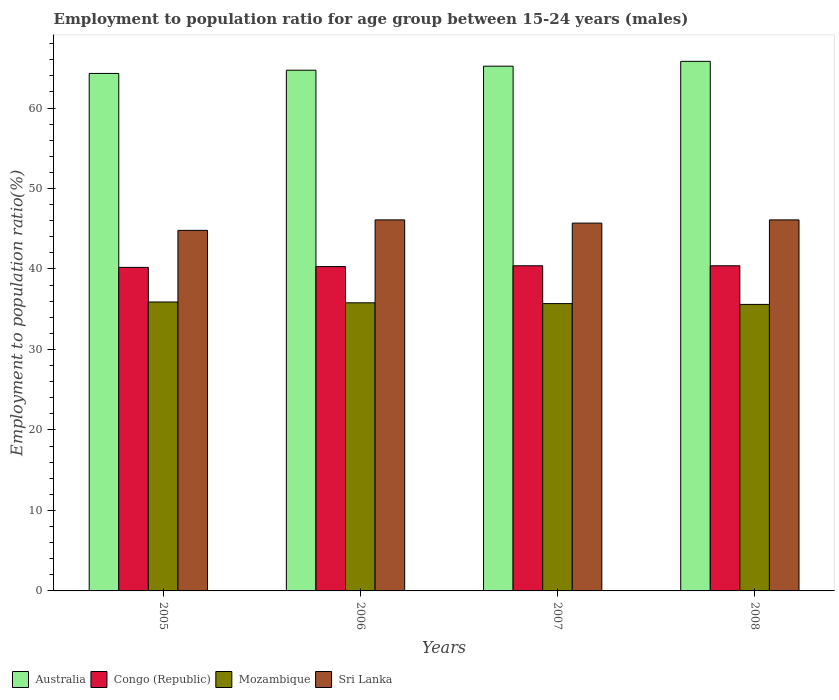How many different coloured bars are there?
Ensure brevity in your answer.  4. How many groups of bars are there?
Provide a succinct answer. 4. How many bars are there on the 3rd tick from the left?
Make the answer very short. 4. What is the employment to population ratio in Congo (Republic) in 2008?
Your response must be concise. 40.4. Across all years, what is the maximum employment to population ratio in Congo (Republic)?
Offer a terse response. 40.4. Across all years, what is the minimum employment to population ratio in Sri Lanka?
Give a very brief answer. 44.8. In which year was the employment to population ratio in Sri Lanka minimum?
Offer a terse response. 2005. What is the total employment to population ratio in Australia in the graph?
Offer a very short reply. 260. What is the difference between the employment to population ratio in Sri Lanka in 2005 and that in 2006?
Provide a short and direct response. -1.3. What is the difference between the employment to population ratio in Sri Lanka in 2008 and the employment to population ratio in Mozambique in 2007?
Offer a terse response. 10.4. What is the average employment to population ratio in Sri Lanka per year?
Your answer should be very brief. 45.67. In the year 2007, what is the difference between the employment to population ratio in Mozambique and employment to population ratio in Sri Lanka?
Provide a succinct answer. -10. What is the ratio of the employment to population ratio in Congo (Republic) in 2007 to that in 2008?
Your answer should be very brief. 1. What is the difference between the highest and the second highest employment to population ratio in Australia?
Give a very brief answer. 0.6. What is the difference between the highest and the lowest employment to population ratio in Mozambique?
Make the answer very short. 0.3. In how many years, is the employment to population ratio in Australia greater than the average employment to population ratio in Australia taken over all years?
Your answer should be compact. 2. What does the 2nd bar from the left in 2007 represents?
Keep it short and to the point. Congo (Republic). What does the 1st bar from the right in 2005 represents?
Ensure brevity in your answer.  Sri Lanka. Is it the case that in every year, the sum of the employment to population ratio in Australia and employment to population ratio in Congo (Republic) is greater than the employment to population ratio in Mozambique?
Your answer should be compact. Yes. How many bars are there?
Provide a succinct answer. 16. Are all the bars in the graph horizontal?
Your answer should be compact. No. How many years are there in the graph?
Make the answer very short. 4. Does the graph contain grids?
Your answer should be compact. No. What is the title of the graph?
Provide a succinct answer. Employment to population ratio for age group between 15-24 years (males). Does "Fragile and conflict affected situations" appear as one of the legend labels in the graph?
Offer a very short reply. No. What is the Employment to population ratio(%) in Australia in 2005?
Keep it short and to the point. 64.3. What is the Employment to population ratio(%) of Congo (Republic) in 2005?
Provide a succinct answer. 40.2. What is the Employment to population ratio(%) in Mozambique in 2005?
Your response must be concise. 35.9. What is the Employment to population ratio(%) in Sri Lanka in 2005?
Your response must be concise. 44.8. What is the Employment to population ratio(%) in Australia in 2006?
Make the answer very short. 64.7. What is the Employment to population ratio(%) of Congo (Republic) in 2006?
Your answer should be compact. 40.3. What is the Employment to population ratio(%) in Mozambique in 2006?
Provide a short and direct response. 35.8. What is the Employment to population ratio(%) of Sri Lanka in 2006?
Provide a succinct answer. 46.1. What is the Employment to population ratio(%) in Australia in 2007?
Provide a short and direct response. 65.2. What is the Employment to population ratio(%) in Congo (Republic) in 2007?
Offer a very short reply. 40.4. What is the Employment to population ratio(%) of Mozambique in 2007?
Your response must be concise. 35.7. What is the Employment to population ratio(%) of Sri Lanka in 2007?
Provide a short and direct response. 45.7. What is the Employment to population ratio(%) in Australia in 2008?
Your response must be concise. 65.8. What is the Employment to population ratio(%) in Congo (Republic) in 2008?
Make the answer very short. 40.4. What is the Employment to population ratio(%) of Mozambique in 2008?
Your answer should be very brief. 35.6. What is the Employment to population ratio(%) in Sri Lanka in 2008?
Your answer should be compact. 46.1. Across all years, what is the maximum Employment to population ratio(%) of Australia?
Offer a very short reply. 65.8. Across all years, what is the maximum Employment to population ratio(%) of Congo (Republic)?
Offer a very short reply. 40.4. Across all years, what is the maximum Employment to population ratio(%) in Mozambique?
Give a very brief answer. 35.9. Across all years, what is the maximum Employment to population ratio(%) in Sri Lanka?
Your response must be concise. 46.1. Across all years, what is the minimum Employment to population ratio(%) in Australia?
Your response must be concise. 64.3. Across all years, what is the minimum Employment to population ratio(%) of Congo (Republic)?
Make the answer very short. 40.2. Across all years, what is the minimum Employment to population ratio(%) of Mozambique?
Your answer should be very brief. 35.6. Across all years, what is the minimum Employment to population ratio(%) in Sri Lanka?
Ensure brevity in your answer.  44.8. What is the total Employment to population ratio(%) of Australia in the graph?
Keep it short and to the point. 260. What is the total Employment to population ratio(%) in Congo (Republic) in the graph?
Offer a terse response. 161.3. What is the total Employment to population ratio(%) in Mozambique in the graph?
Offer a very short reply. 143. What is the total Employment to population ratio(%) in Sri Lanka in the graph?
Your answer should be very brief. 182.7. What is the difference between the Employment to population ratio(%) of Congo (Republic) in 2005 and that in 2006?
Provide a short and direct response. -0.1. What is the difference between the Employment to population ratio(%) of Mozambique in 2005 and that in 2006?
Give a very brief answer. 0.1. What is the difference between the Employment to population ratio(%) in Australia in 2005 and that in 2007?
Provide a succinct answer. -0.9. What is the difference between the Employment to population ratio(%) in Mozambique in 2005 and that in 2008?
Offer a very short reply. 0.3. What is the difference between the Employment to population ratio(%) of Mozambique in 2006 and that in 2007?
Offer a terse response. 0.1. What is the difference between the Employment to population ratio(%) in Australia in 2007 and that in 2008?
Provide a short and direct response. -0.6. What is the difference between the Employment to population ratio(%) of Sri Lanka in 2007 and that in 2008?
Your answer should be compact. -0.4. What is the difference between the Employment to population ratio(%) of Australia in 2005 and the Employment to population ratio(%) of Mozambique in 2006?
Keep it short and to the point. 28.5. What is the difference between the Employment to population ratio(%) of Congo (Republic) in 2005 and the Employment to population ratio(%) of Mozambique in 2006?
Your response must be concise. 4.4. What is the difference between the Employment to population ratio(%) in Mozambique in 2005 and the Employment to population ratio(%) in Sri Lanka in 2006?
Offer a terse response. -10.2. What is the difference between the Employment to population ratio(%) in Australia in 2005 and the Employment to population ratio(%) in Congo (Republic) in 2007?
Give a very brief answer. 23.9. What is the difference between the Employment to population ratio(%) of Australia in 2005 and the Employment to population ratio(%) of Mozambique in 2007?
Offer a very short reply. 28.6. What is the difference between the Employment to population ratio(%) of Australia in 2005 and the Employment to population ratio(%) of Sri Lanka in 2007?
Provide a short and direct response. 18.6. What is the difference between the Employment to population ratio(%) in Congo (Republic) in 2005 and the Employment to population ratio(%) in Sri Lanka in 2007?
Provide a succinct answer. -5.5. What is the difference between the Employment to population ratio(%) in Australia in 2005 and the Employment to population ratio(%) in Congo (Republic) in 2008?
Offer a terse response. 23.9. What is the difference between the Employment to population ratio(%) in Australia in 2005 and the Employment to population ratio(%) in Mozambique in 2008?
Offer a very short reply. 28.7. What is the difference between the Employment to population ratio(%) of Mozambique in 2005 and the Employment to population ratio(%) of Sri Lanka in 2008?
Keep it short and to the point. -10.2. What is the difference between the Employment to population ratio(%) in Australia in 2006 and the Employment to population ratio(%) in Congo (Republic) in 2007?
Offer a terse response. 24.3. What is the difference between the Employment to population ratio(%) in Australia in 2006 and the Employment to population ratio(%) in Mozambique in 2007?
Provide a succinct answer. 29. What is the difference between the Employment to population ratio(%) of Congo (Republic) in 2006 and the Employment to population ratio(%) of Mozambique in 2007?
Provide a short and direct response. 4.6. What is the difference between the Employment to population ratio(%) of Australia in 2006 and the Employment to population ratio(%) of Congo (Republic) in 2008?
Keep it short and to the point. 24.3. What is the difference between the Employment to population ratio(%) of Australia in 2006 and the Employment to population ratio(%) of Mozambique in 2008?
Your answer should be compact. 29.1. What is the difference between the Employment to population ratio(%) in Australia in 2006 and the Employment to population ratio(%) in Sri Lanka in 2008?
Offer a terse response. 18.6. What is the difference between the Employment to population ratio(%) of Australia in 2007 and the Employment to population ratio(%) of Congo (Republic) in 2008?
Provide a short and direct response. 24.8. What is the difference between the Employment to population ratio(%) of Australia in 2007 and the Employment to population ratio(%) of Mozambique in 2008?
Offer a very short reply. 29.6. What is the difference between the Employment to population ratio(%) in Congo (Republic) in 2007 and the Employment to population ratio(%) in Sri Lanka in 2008?
Your response must be concise. -5.7. What is the difference between the Employment to population ratio(%) of Mozambique in 2007 and the Employment to population ratio(%) of Sri Lanka in 2008?
Offer a very short reply. -10.4. What is the average Employment to population ratio(%) of Australia per year?
Provide a succinct answer. 65. What is the average Employment to population ratio(%) of Congo (Republic) per year?
Give a very brief answer. 40.33. What is the average Employment to population ratio(%) in Mozambique per year?
Your answer should be compact. 35.75. What is the average Employment to population ratio(%) in Sri Lanka per year?
Provide a succinct answer. 45.67. In the year 2005, what is the difference between the Employment to population ratio(%) of Australia and Employment to population ratio(%) of Congo (Republic)?
Your response must be concise. 24.1. In the year 2005, what is the difference between the Employment to population ratio(%) of Australia and Employment to population ratio(%) of Mozambique?
Your answer should be very brief. 28.4. In the year 2005, what is the difference between the Employment to population ratio(%) of Australia and Employment to population ratio(%) of Sri Lanka?
Your answer should be compact. 19.5. In the year 2005, what is the difference between the Employment to population ratio(%) of Mozambique and Employment to population ratio(%) of Sri Lanka?
Make the answer very short. -8.9. In the year 2006, what is the difference between the Employment to population ratio(%) of Australia and Employment to population ratio(%) of Congo (Republic)?
Ensure brevity in your answer.  24.4. In the year 2006, what is the difference between the Employment to population ratio(%) in Australia and Employment to population ratio(%) in Mozambique?
Your response must be concise. 28.9. In the year 2006, what is the difference between the Employment to population ratio(%) of Congo (Republic) and Employment to population ratio(%) of Sri Lanka?
Ensure brevity in your answer.  -5.8. In the year 2006, what is the difference between the Employment to population ratio(%) in Mozambique and Employment to population ratio(%) in Sri Lanka?
Offer a very short reply. -10.3. In the year 2007, what is the difference between the Employment to population ratio(%) in Australia and Employment to population ratio(%) in Congo (Republic)?
Your response must be concise. 24.8. In the year 2007, what is the difference between the Employment to population ratio(%) in Australia and Employment to population ratio(%) in Mozambique?
Provide a short and direct response. 29.5. In the year 2007, what is the difference between the Employment to population ratio(%) in Australia and Employment to population ratio(%) in Sri Lanka?
Provide a short and direct response. 19.5. In the year 2007, what is the difference between the Employment to population ratio(%) of Congo (Republic) and Employment to population ratio(%) of Mozambique?
Provide a succinct answer. 4.7. In the year 2008, what is the difference between the Employment to population ratio(%) in Australia and Employment to population ratio(%) in Congo (Republic)?
Provide a short and direct response. 25.4. In the year 2008, what is the difference between the Employment to population ratio(%) of Australia and Employment to population ratio(%) of Mozambique?
Make the answer very short. 30.2. In the year 2008, what is the difference between the Employment to population ratio(%) in Australia and Employment to population ratio(%) in Sri Lanka?
Provide a short and direct response. 19.7. In the year 2008, what is the difference between the Employment to population ratio(%) in Congo (Republic) and Employment to population ratio(%) in Mozambique?
Your answer should be very brief. 4.8. In the year 2008, what is the difference between the Employment to population ratio(%) in Mozambique and Employment to population ratio(%) in Sri Lanka?
Keep it short and to the point. -10.5. What is the ratio of the Employment to population ratio(%) in Mozambique in 2005 to that in 2006?
Offer a terse response. 1. What is the ratio of the Employment to population ratio(%) of Sri Lanka in 2005 to that in 2006?
Provide a short and direct response. 0.97. What is the ratio of the Employment to population ratio(%) of Australia in 2005 to that in 2007?
Provide a short and direct response. 0.99. What is the ratio of the Employment to population ratio(%) in Mozambique in 2005 to that in 2007?
Offer a very short reply. 1.01. What is the ratio of the Employment to population ratio(%) in Sri Lanka in 2005 to that in 2007?
Offer a very short reply. 0.98. What is the ratio of the Employment to population ratio(%) of Australia in 2005 to that in 2008?
Keep it short and to the point. 0.98. What is the ratio of the Employment to population ratio(%) in Mozambique in 2005 to that in 2008?
Give a very brief answer. 1.01. What is the ratio of the Employment to population ratio(%) of Sri Lanka in 2005 to that in 2008?
Offer a very short reply. 0.97. What is the ratio of the Employment to population ratio(%) in Mozambique in 2006 to that in 2007?
Your answer should be compact. 1. What is the ratio of the Employment to population ratio(%) in Sri Lanka in 2006 to that in 2007?
Give a very brief answer. 1.01. What is the ratio of the Employment to population ratio(%) of Australia in 2006 to that in 2008?
Offer a very short reply. 0.98. What is the ratio of the Employment to population ratio(%) in Mozambique in 2006 to that in 2008?
Provide a short and direct response. 1.01. What is the ratio of the Employment to population ratio(%) of Australia in 2007 to that in 2008?
Offer a very short reply. 0.99. What is the ratio of the Employment to population ratio(%) in Sri Lanka in 2007 to that in 2008?
Make the answer very short. 0.99. What is the difference between the highest and the second highest Employment to population ratio(%) in Australia?
Keep it short and to the point. 0.6. What is the difference between the highest and the second highest Employment to population ratio(%) in Congo (Republic)?
Keep it short and to the point. 0. What is the difference between the highest and the second highest Employment to population ratio(%) of Mozambique?
Provide a succinct answer. 0.1. What is the difference between the highest and the lowest Employment to population ratio(%) of Congo (Republic)?
Keep it short and to the point. 0.2. 